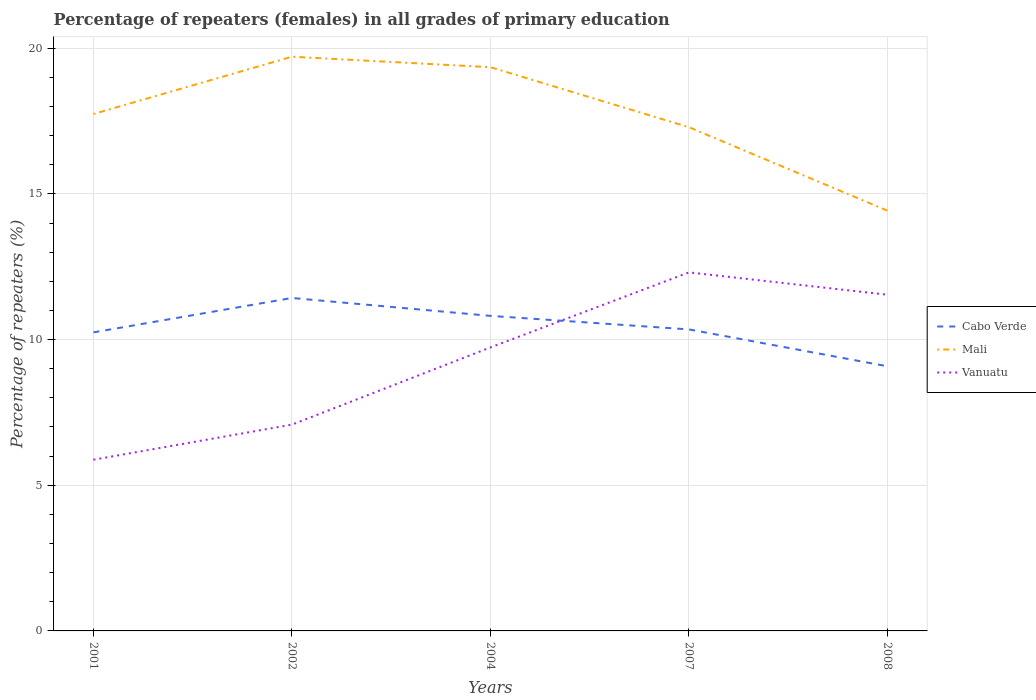Is the number of lines equal to the number of legend labels?
Your answer should be compact. Yes. Across all years, what is the maximum percentage of repeaters (females) in Mali?
Your answer should be very brief. 14.42. What is the total percentage of repeaters (females) in Mali in the graph?
Your response must be concise. -1.61. What is the difference between the highest and the second highest percentage of repeaters (females) in Cabo Verde?
Give a very brief answer. 2.34. What is the difference between the highest and the lowest percentage of repeaters (females) in Cabo Verde?
Offer a very short reply. 2. Is the percentage of repeaters (females) in Cabo Verde strictly greater than the percentage of repeaters (females) in Mali over the years?
Offer a very short reply. Yes. How many lines are there?
Offer a very short reply. 3. How many years are there in the graph?
Provide a short and direct response. 5. What is the difference between two consecutive major ticks on the Y-axis?
Offer a terse response. 5. Does the graph contain any zero values?
Provide a succinct answer. No. Does the graph contain grids?
Keep it short and to the point. Yes. How many legend labels are there?
Your answer should be very brief. 3. What is the title of the graph?
Your answer should be very brief. Percentage of repeaters (females) in all grades of primary education. Does "Somalia" appear as one of the legend labels in the graph?
Offer a terse response. No. What is the label or title of the X-axis?
Give a very brief answer. Years. What is the label or title of the Y-axis?
Your answer should be very brief. Percentage of repeaters (%). What is the Percentage of repeaters (%) of Cabo Verde in 2001?
Keep it short and to the point. 10.25. What is the Percentage of repeaters (%) of Mali in 2001?
Offer a terse response. 17.74. What is the Percentage of repeaters (%) of Vanuatu in 2001?
Your answer should be very brief. 5.88. What is the Percentage of repeaters (%) of Cabo Verde in 2002?
Give a very brief answer. 11.43. What is the Percentage of repeaters (%) in Mali in 2002?
Your answer should be compact. 19.71. What is the Percentage of repeaters (%) of Vanuatu in 2002?
Your answer should be compact. 7.08. What is the Percentage of repeaters (%) in Cabo Verde in 2004?
Ensure brevity in your answer.  10.81. What is the Percentage of repeaters (%) in Mali in 2004?
Keep it short and to the point. 19.35. What is the Percentage of repeaters (%) in Vanuatu in 2004?
Provide a succinct answer. 9.73. What is the Percentage of repeaters (%) in Cabo Verde in 2007?
Give a very brief answer. 10.35. What is the Percentage of repeaters (%) in Mali in 2007?
Offer a very short reply. 17.29. What is the Percentage of repeaters (%) in Vanuatu in 2007?
Keep it short and to the point. 12.31. What is the Percentage of repeaters (%) in Cabo Verde in 2008?
Make the answer very short. 9.08. What is the Percentage of repeaters (%) in Mali in 2008?
Make the answer very short. 14.42. What is the Percentage of repeaters (%) of Vanuatu in 2008?
Your answer should be compact. 11.54. Across all years, what is the maximum Percentage of repeaters (%) of Cabo Verde?
Your answer should be compact. 11.43. Across all years, what is the maximum Percentage of repeaters (%) of Mali?
Your answer should be compact. 19.71. Across all years, what is the maximum Percentage of repeaters (%) of Vanuatu?
Your answer should be compact. 12.31. Across all years, what is the minimum Percentage of repeaters (%) in Cabo Verde?
Provide a short and direct response. 9.08. Across all years, what is the minimum Percentage of repeaters (%) in Mali?
Your response must be concise. 14.42. Across all years, what is the minimum Percentage of repeaters (%) of Vanuatu?
Your answer should be compact. 5.88. What is the total Percentage of repeaters (%) of Cabo Verde in the graph?
Provide a succinct answer. 51.92. What is the total Percentage of repeaters (%) of Mali in the graph?
Provide a short and direct response. 88.51. What is the total Percentage of repeaters (%) of Vanuatu in the graph?
Offer a very short reply. 46.53. What is the difference between the Percentage of repeaters (%) in Cabo Verde in 2001 and that in 2002?
Provide a short and direct response. -1.18. What is the difference between the Percentage of repeaters (%) of Mali in 2001 and that in 2002?
Your answer should be compact. -1.97. What is the difference between the Percentage of repeaters (%) in Vanuatu in 2001 and that in 2002?
Your response must be concise. -1.2. What is the difference between the Percentage of repeaters (%) of Cabo Verde in 2001 and that in 2004?
Offer a terse response. -0.57. What is the difference between the Percentage of repeaters (%) in Mali in 2001 and that in 2004?
Give a very brief answer. -1.61. What is the difference between the Percentage of repeaters (%) in Vanuatu in 2001 and that in 2004?
Offer a very short reply. -3.86. What is the difference between the Percentage of repeaters (%) of Cabo Verde in 2001 and that in 2007?
Ensure brevity in your answer.  -0.1. What is the difference between the Percentage of repeaters (%) of Mali in 2001 and that in 2007?
Your answer should be very brief. 0.45. What is the difference between the Percentage of repeaters (%) of Vanuatu in 2001 and that in 2007?
Provide a succinct answer. -6.43. What is the difference between the Percentage of repeaters (%) of Cabo Verde in 2001 and that in 2008?
Your answer should be very brief. 1.16. What is the difference between the Percentage of repeaters (%) in Mali in 2001 and that in 2008?
Make the answer very short. 3.32. What is the difference between the Percentage of repeaters (%) in Vanuatu in 2001 and that in 2008?
Provide a short and direct response. -5.66. What is the difference between the Percentage of repeaters (%) in Cabo Verde in 2002 and that in 2004?
Give a very brief answer. 0.61. What is the difference between the Percentage of repeaters (%) in Mali in 2002 and that in 2004?
Provide a short and direct response. 0.36. What is the difference between the Percentage of repeaters (%) in Vanuatu in 2002 and that in 2004?
Keep it short and to the point. -2.65. What is the difference between the Percentage of repeaters (%) of Cabo Verde in 2002 and that in 2007?
Your response must be concise. 1.08. What is the difference between the Percentage of repeaters (%) of Mali in 2002 and that in 2007?
Your answer should be very brief. 2.42. What is the difference between the Percentage of repeaters (%) of Vanuatu in 2002 and that in 2007?
Provide a succinct answer. -5.22. What is the difference between the Percentage of repeaters (%) in Cabo Verde in 2002 and that in 2008?
Your answer should be very brief. 2.34. What is the difference between the Percentage of repeaters (%) of Mali in 2002 and that in 2008?
Offer a very short reply. 5.28. What is the difference between the Percentage of repeaters (%) of Vanuatu in 2002 and that in 2008?
Make the answer very short. -4.46. What is the difference between the Percentage of repeaters (%) of Cabo Verde in 2004 and that in 2007?
Offer a very short reply. 0.46. What is the difference between the Percentage of repeaters (%) of Mali in 2004 and that in 2007?
Your answer should be compact. 2.06. What is the difference between the Percentage of repeaters (%) in Vanuatu in 2004 and that in 2007?
Your response must be concise. -2.57. What is the difference between the Percentage of repeaters (%) of Cabo Verde in 2004 and that in 2008?
Keep it short and to the point. 1.73. What is the difference between the Percentage of repeaters (%) in Mali in 2004 and that in 2008?
Offer a very short reply. 4.92. What is the difference between the Percentage of repeaters (%) of Vanuatu in 2004 and that in 2008?
Your response must be concise. -1.81. What is the difference between the Percentage of repeaters (%) in Cabo Verde in 2007 and that in 2008?
Provide a succinct answer. 1.27. What is the difference between the Percentage of repeaters (%) in Mali in 2007 and that in 2008?
Provide a succinct answer. 2.86. What is the difference between the Percentage of repeaters (%) in Vanuatu in 2007 and that in 2008?
Your answer should be very brief. 0.77. What is the difference between the Percentage of repeaters (%) in Cabo Verde in 2001 and the Percentage of repeaters (%) in Mali in 2002?
Offer a terse response. -9.46. What is the difference between the Percentage of repeaters (%) of Cabo Verde in 2001 and the Percentage of repeaters (%) of Vanuatu in 2002?
Give a very brief answer. 3.17. What is the difference between the Percentage of repeaters (%) of Mali in 2001 and the Percentage of repeaters (%) of Vanuatu in 2002?
Your answer should be compact. 10.66. What is the difference between the Percentage of repeaters (%) in Cabo Verde in 2001 and the Percentage of repeaters (%) in Mali in 2004?
Keep it short and to the point. -9.1. What is the difference between the Percentage of repeaters (%) in Cabo Verde in 2001 and the Percentage of repeaters (%) in Vanuatu in 2004?
Give a very brief answer. 0.52. What is the difference between the Percentage of repeaters (%) in Mali in 2001 and the Percentage of repeaters (%) in Vanuatu in 2004?
Provide a succinct answer. 8.01. What is the difference between the Percentage of repeaters (%) of Cabo Verde in 2001 and the Percentage of repeaters (%) of Mali in 2007?
Your answer should be very brief. -7.04. What is the difference between the Percentage of repeaters (%) in Cabo Verde in 2001 and the Percentage of repeaters (%) in Vanuatu in 2007?
Your answer should be very brief. -2.06. What is the difference between the Percentage of repeaters (%) of Mali in 2001 and the Percentage of repeaters (%) of Vanuatu in 2007?
Provide a succinct answer. 5.44. What is the difference between the Percentage of repeaters (%) of Cabo Verde in 2001 and the Percentage of repeaters (%) of Mali in 2008?
Make the answer very short. -4.18. What is the difference between the Percentage of repeaters (%) of Cabo Verde in 2001 and the Percentage of repeaters (%) of Vanuatu in 2008?
Ensure brevity in your answer.  -1.29. What is the difference between the Percentage of repeaters (%) of Mali in 2001 and the Percentage of repeaters (%) of Vanuatu in 2008?
Give a very brief answer. 6.2. What is the difference between the Percentage of repeaters (%) of Cabo Verde in 2002 and the Percentage of repeaters (%) of Mali in 2004?
Ensure brevity in your answer.  -7.92. What is the difference between the Percentage of repeaters (%) of Cabo Verde in 2002 and the Percentage of repeaters (%) of Vanuatu in 2004?
Keep it short and to the point. 1.7. What is the difference between the Percentage of repeaters (%) of Mali in 2002 and the Percentage of repeaters (%) of Vanuatu in 2004?
Your response must be concise. 9.98. What is the difference between the Percentage of repeaters (%) in Cabo Verde in 2002 and the Percentage of repeaters (%) in Mali in 2007?
Your response must be concise. -5.86. What is the difference between the Percentage of repeaters (%) in Cabo Verde in 2002 and the Percentage of repeaters (%) in Vanuatu in 2007?
Give a very brief answer. -0.88. What is the difference between the Percentage of repeaters (%) in Mali in 2002 and the Percentage of repeaters (%) in Vanuatu in 2007?
Offer a very short reply. 7.4. What is the difference between the Percentage of repeaters (%) of Cabo Verde in 2002 and the Percentage of repeaters (%) of Mali in 2008?
Offer a very short reply. -3. What is the difference between the Percentage of repeaters (%) in Cabo Verde in 2002 and the Percentage of repeaters (%) in Vanuatu in 2008?
Your response must be concise. -0.11. What is the difference between the Percentage of repeaters (%) of Mali in 2002 and the Percentage of repeaters (%) of Vanuatu in 2008?
Give a very brief answer. 8.17. What is the difference between the Percentage of repeaters (%) of Cabo Verde in 2004 and the Percentage of repeaters (%) of Mali in 2007?
Your answer should be very brief. -6.47. What is the difference between the Percentage of repeaters (%) in Cabo Verde in 2004 and the Percentage of repeaters (%) in Vanuatu in 2007?
Keep it short and to the point. -1.49. What is the difference between the Percentage of repeaters (%) of Mali in 2004 and the Percentage of repeaters (%) of Vanuatu in 2007?
Offer a very short reply. 7.04. What is the difference between the Percentage of repeaters (%) of Cabo Verde in 2004 and the Percentage of repeaters (%) of Mali in 2008?
Ensure brevity in your answer.  -3.61. What is the difference between the Percentage of repeaters (%) in Cabo Verde in 2004 and the Percentage of repeaters (%) in Vanuatu in 2008?
Offer a very short reply. -0.73. What is the difference between the Percentage of repeaters (%) in Mali in 2004 and the Percentage of repeaters (%) in Vanuatu in 2008?
Ensure brevity in your answer.  7.81. What is the difference between the Percentage of repeaters (%) in Cabo Verde in 2007 and the Percentage of repeaters (%) in Mali in 2008?
Your answer should be very brief. -4.08. What is the difference between the Percentage of repeaters (%) in Cabo Verde in 2007 and the Percentage of repeaters (%) in Vanuatu in 2008?
Provide a succinct answer. -1.19. What is the difference between the Percentage of repeaters (%) in Mali in 2007 and the Percentage of repeaters (%) in Vanuatu in 2008?
Ensure brevity in your answer.  5.75. What is the average Percentage of repeaters (%) of Cabo Verde per year?
Keep it short and to the point. 10.38. What is the average Percentage of repeaters (%) of Mali per year?
Make the answer very short. 17.7. What is the average Percentage of repeaters (%) in Vanuatu per year?
Your answer should be compact. 9.31. In the year 2001, what is the difference between the Percentage of repeaters (%) in Cabo Verde and Percentage of repeaters (%) in Mali?
Offer a terse response. -7.5. In the year 2001, what is the difference between the Percentage of repeaters (%) of Cabo Verde and Percentage of repeaters (%) of Vanuatu?
Offer a terse response. 4.37. In the year 2001, what is the difference between the Percentage of repeaters (%) in Mali and Percentage of repeaters (%) in Vanuatu?
Your answer should be very brief. 11.87. In the year 2002, what is the difference between the Percentage of repeaters (%) in Cabo Verde and Percentage of repeaters (%) in Mali?
Keep it short and to the point. -8.28. In the year 2002, what is the difference between the Percentage of repeaters (%) of Cabo Verde and Percentage of repeaters (%) of Vanuatu?
Ensure brevity in your answer.  4.35. In the year 2002, what is the difference between the Percentage of repeaters (%) of Mali and Percentage of repeaters (%) of Vanuatu?
Your answer should be very brief. 12.63. In the year 2004, what is the difference between the Percentage of repeaters (%) in Cabo Verde and Percentage of repeaters (%) in Mali?
Provide a succinct answer. -8.54. In the year 2004, what is the difference between the Percentage of repeaters (%) of Cabo Verde and Percentage of repeaters (%) of Vanuatu?
Offer a very short reply. 1.08. In the year 2004, what is the difference between the Percentage of repeaters (%) in Mali and Percentage of repeaters (%) in Vanuatu?
Your answer should be compact. 9.62. In the year 2007, what is the difference between the Percentage of repeaters (%) in Cabo Verde and Percentage of repeaters (%) in Mali?
Provide a succinct answer. -6.94. In the year 2007, what is the difference between the Percentage of repeaters (%) of Cabo Verde and Percentage of repeaters (%) of Vanuatu?
Your answer should be very brief. -1.96. In the year 2007, what is the difference between the Percentage of repeaters (%) in Mali and Percentage of repeaters (%) in Vanuatu?
Keep it short and to the point. 4.98. In the year 2008, what is the difference between the Percentage of repeaters (%) in Cabo Verde and Percentage of repeaters (%) in Mali?
Keep it short and to the point. -5.34. In the year 2008, what is the difference between the Percentage of repeaters (%) of Cabo Verde and Percentage of repeaters (%) of Vanuatu?
Your answer should be very brief. -2.46. In the year 2008, what is the difference between the Percentage of repeaters (%) in Mali and Percentage of repeaters (%) in Vanuatu?
Provide a short and direct response. 2.88. What is the ratio of the Percentage of repeaters (%) of Cabo Verde in 2001 to that in 2002?
Your answer should be compact. 0.9. What is the ratio of the Percentage of repeaters (%) in Mali in 2001 to that in 2002?
Provide a short and direct response. 0.9. What is the ratio of the Percentage of repeaters (%) of Vanuatu in 2001 to that in 2002?
Your answer should be very brief. 0.83. What is the ratio of the Percentage of repeaters (%) of Cabo Verde in 2001 to that in 2004?
Keep it short and to the point. 0.95. What is the ratio of the Percentage of repeaters (%) of Mali in 2001 to that in 2004?
Your answer should be very brief. 0.92. What is the ratio of the Percentage of repeaters (%) of Vanuatu in 2001 to that in 2004?
Keep it short and to the point. 0.6. What is the ratio of the Percentage of repeaters (%) of Cabo Verde in 2001 to that in 2007?
Keep it short and to the point. 0.99. What is the ratio of the Percentage of repeaters (%) in Mali in 2001 to that in 2007?
Offer a terse response. 1.03. What is the ratio of the Percentage of repeaters (%) in Vanuatu in 2001 to that in 2007?
Provide a short and direct response. 0.48. What is the ratio of the Percentage of repeaters (%) in Cabo Verde in 2001 to that in 2008?
Your answer should be very brief. 1.13. What is the ratio of the Percentage of repeaters (%) of Mali in 2001 to that in 2008?
Your answer should be compact. 1.23. What is the ratio of the Percentage of repeaters (%) in Vanuatu in 2001 to that in 2008?
Make the answer very short. 0.51. What is the ratio of the Percentage of repeaters (%) of Cabo Verde in 2002 to that in 2004?
Provide a short and direct response. 1.06. What is the ratio of the Percentage of repeaters (%) in Mali in 2002 to that in 2004?
Your answer should be very brief. 1.02. What is the ratio of the Percentage of repeaters (%) in Vanuatu in 2002 to that in 2004?
Provide a succinct answer. 0.73. What is the ratio of the Percentage of repeaters (%) of Cabo Verde in 2002 to that in 2007?
Provide a succinct answer. 1.1. What is the ratio of the Percentage of repeaters (%) of Mali in 2002 to that in 2007?
Your answer should be very brief. 1.14. What is the ratio of the Percentage of repeaters (%) of Vanuatu in 2002 to that in 2007?
Provide a short and direct response. 0.58. What is the ratio of the Percentage of repeaters (%) of Cabo Verde in 2002 to that in 2008?
Offer a terse response. 1.26. What is the ratio of the Percentage of repeaters (%) of Mali in 2002 to that in 2008?
Your response must be concise. 1.37. What is the ratio of the Percentage of repeaters (%) of Vanuatu in 2002 to that in 2008?
Ensure brevity in your answer.  0.61. What is the ratio of the Percentage of repeaters (%) in Cabo Verde in 2004 to that in 2007?
Provide a succinct answer. 1.04. What is the ratio of the Percentage of repeaters (%) in Mali in 2004 to that in 2007?
Offer a terse response. 1.12. What is the ratio of the Percentage of repeaters (%) in Vanuatu in 2004 to that in 2007?
Your answer should be very brief. 0.79. What is the ratio of the Percentage of repeaters (%) in Cabo Verde in 2004 to that in 2008?
Your answer should be compact. 1.19. What is the ratio of the Percentage of repeaters (%) of Mali in 2004 to that in 2008?
Keep it short and to the point. 1.34. What is the ratio of the Percentage of repeaters (%) of Vanuatu in 2004 to that in 2008?
Give a very brief answer. 0.84. What is the ratio of the Percentage of repeaters (%) of Cabo Verde in 2007 to that in 2008?
Ensure brevity in your answer.  1.14. What is the ratio of the Percentage of repeaters (%) in Mali in 2007 to that in 2008?
Make the answer very short. 1.2. What is the ratio of the Percentage of repeaters (%) of Vanuatu in 2007 to that in 2008?
Keep it short and to the point. 1.07. What is the difference between the highest and the second highest Percentage of repeaters (%) in Cabo Verde?
Give a very brief answer. 0.61. What is the difference between the highest and the second highest Percentage of repeaters (%) of Mali?
Keep it short and to the point. 0.36. What is the difference between the highest and the second highest Percentage of repeaters (%) of Vanuatu?
Offer a very short reply. 0.77. What is the difference between the highest and the lowest Percentage of repeaters (%) in Cabo Verde?
Your answer should be compact. 2.34. What is the difference between the highest and the lowest Percentage of repeaters (%) of Mali?
Provide a succinct answer. 5.28. What is the difference between the highest and the lowest Percentage of repeaters (%) of Vanuatu?
Your answer should be compact. 6.43. 